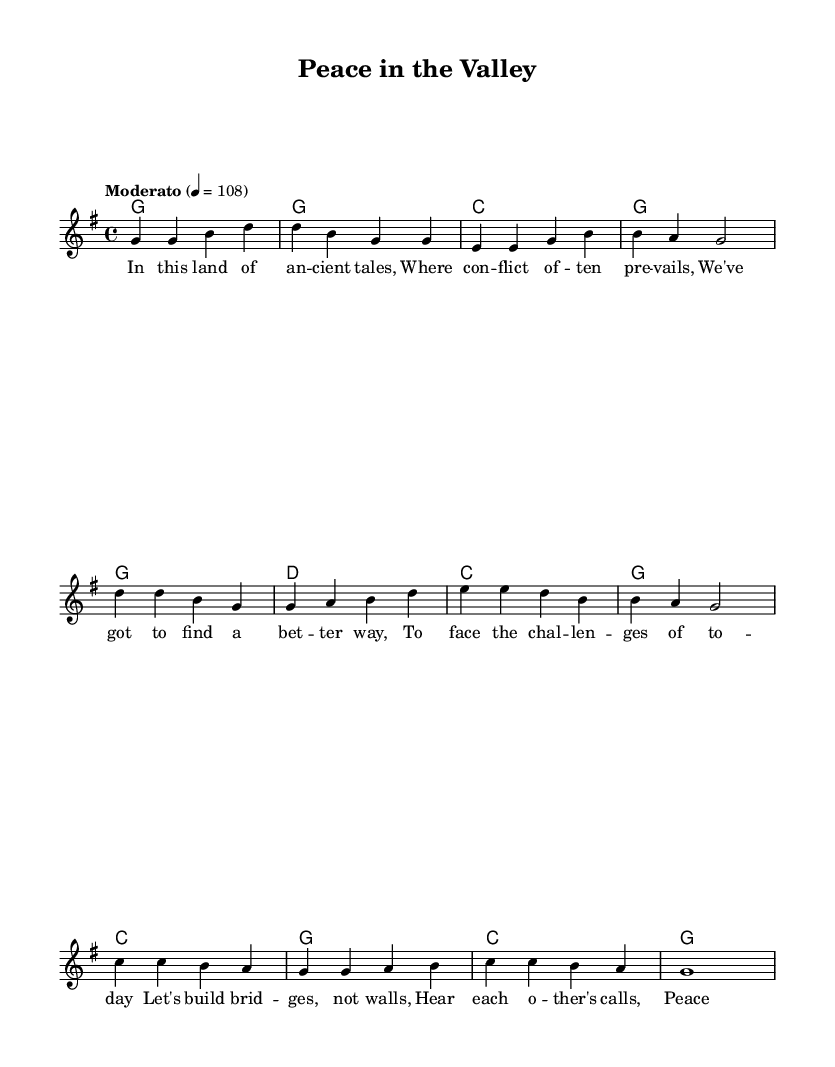What is the key signature of this music? The key signature is G major, which has one sharp (F#). It is indicated by the key symbol at the beginning of the staff.
Answer: G major What is the time signature of the piece? The time signature is 4/4, which is shown at the beginning of the staff. It indicates there are four beats in a measure and a quarter note gets one beat.
Answer: 4/4 What is the tempo marking of the music? The tempo marking is "Moderato" and it is set at 108 beats per minute. This suggests a moderate pace for the song.
Answer: Moderato 108 How many verses are there in the song? There is one verse indicated in the lyrics section, followed by the chorus and bridge. The structured pattern suggests a single verse is presented before the chorus.
Answer: One In which section is the phrase "Peace in the valley, that's our dream" found? This phrase is part of the chorus section, which follows the verse in the structure of the song. The lyrics are neatly aligned under the melody indicating their position.
Answer: Chorus What is the overall message of the lyrics? The lyrics advocate for non-violence and conflict resolution, as indicated by phrases discussing bridges instead of walls and the call for peace. This is evident from the identified lyrics throughout the song sections.
Answer: Non-violence 